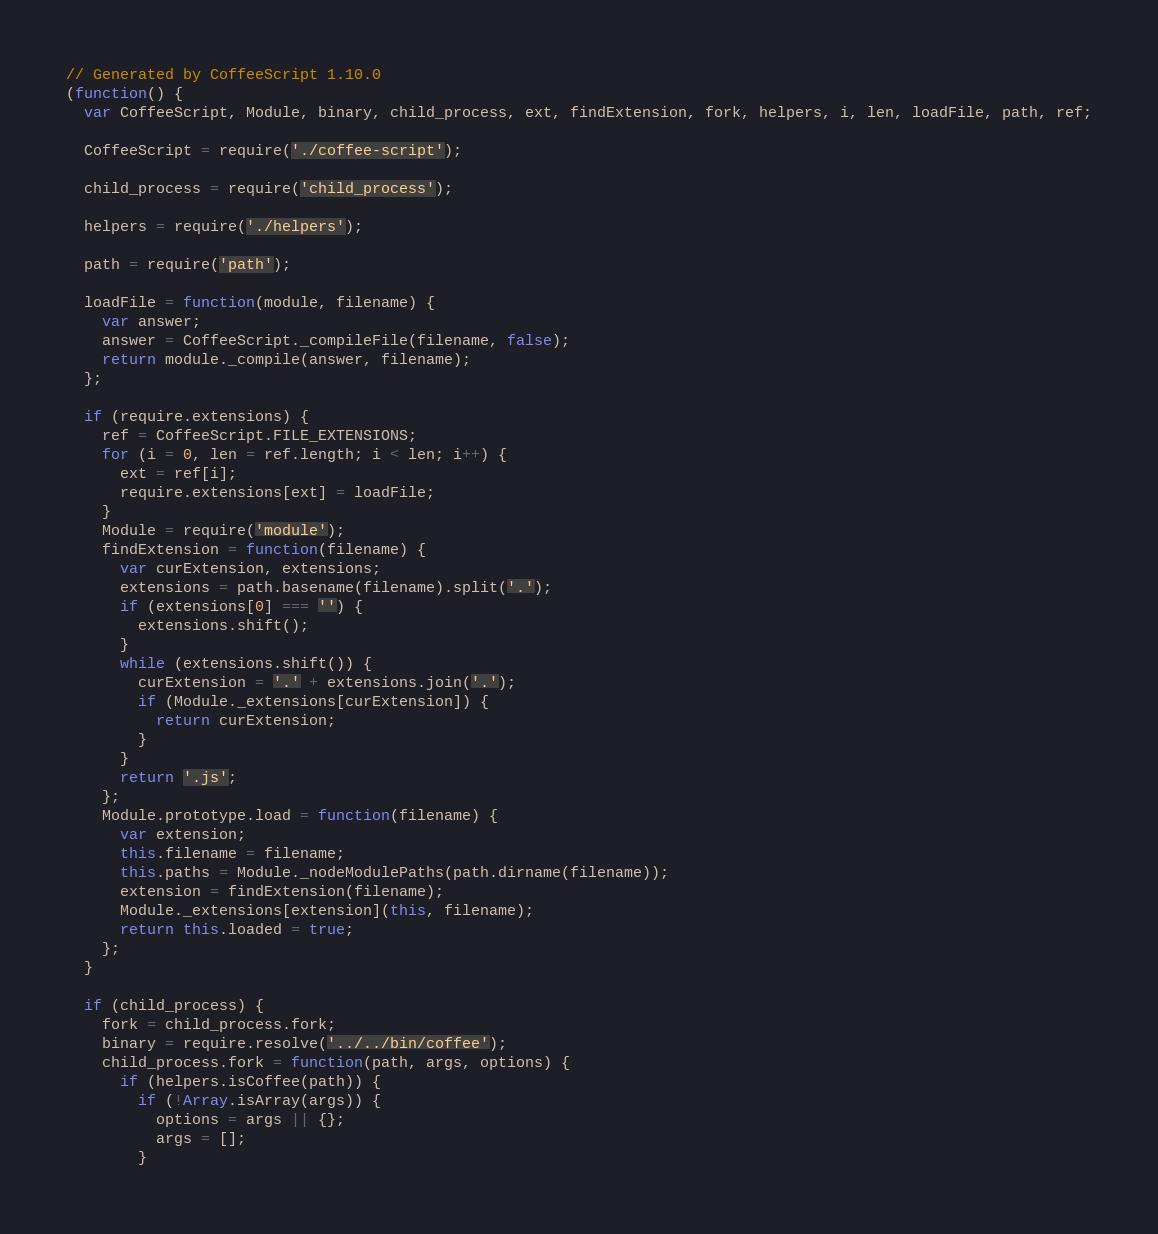<code> <loc_0><loc_0><loc_500><loc_500><_JavaScript_>// Generated by CoffeeScript 1.10.0
(function() {
  var CoffeeScript, Module, binary, child_process, ext, findExtension, fork, helpers, i, len, loadFile, path, ref;

  CoffeeScript = require('./coffee-script');

  child_process = require('child_process');

  helpers = require('./helpers');

  path = require('path');

  loadFile = function(module, filename) {
    var answer;
    answer = CoffeeScript._compileFile(filename, false);
    return module._compile(answer, filename);
  };

  if (require.extensions) {
    ref = CoffeeScript.FILE_EXTENSIONS;
    for (i = 0, len = ref.length; i < len; i++) {
      ext = ref[i];
      require.extensions[ext] = loadFile;
    }
    Module = require('module');
    findExtension = function(filename) {
      var curExtension, extensions;
      extensions = path.basename(filename).split('.');
      if (extensions[0] === '') {
        extensions.shift();
      }
      while (extensions.shift()) {
        curExtension = '.' + extensions.join('.');
        if (Module._extensions[curExtension]) {
          return curExtension;
        }
      }
      return '.js';
    };
    Module.prototype.load = function(filename) {
      var extension;
      this.filename = filename;
      this.paths = Module._nodeModulePaths(path.dirname(filename));
      extension = findExtension(filename);
      Module._extensions[extension](this, filename);
      return this.loaded = true;
    };
  }

  if (child_process) {
    fork = child_process.fork;
    binary = require.resolve('../../bin/coffee');
    child_process.fork = function(path, args, options) {
      if (helpers.isCoffee(path)) {
        if (!Array.isArray(args)) {
          options = args || {};
          args = [];
        }</code> 